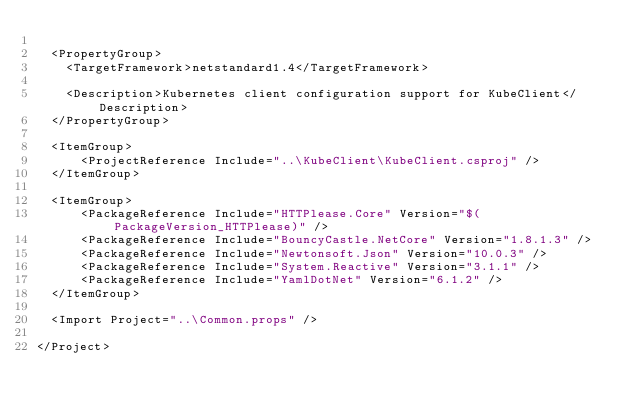<code> <loc_0><loc_0><loc_500><loc_500><_XML_>
  <PropertyGroup>
    <TargetFramework>netstandard1.4</TargetFramework>

    <Description>Kubernetes client configuration support for KubeClient</Description>
  </PropertyGroup>

  <ItemGroup>
      <ProjectReference Include="..\KubeClient\KubeClient.csproj" />
  </ItemGroup>

  <ItemGroup>
      <PackageReference Include="HTTPlease.Core" Version="$(PackageVersion_HTTPlease)" />
      <PackageReference Include="BouncyCastle.NetCore" Version="1.8.1.3" />
      <PackageReference Include="Newtonsoft.Json" Version="10.0.3" />
      <PackageReference Include="System.Reactive" Version="3.1.1" />
      <PackageReference Include="YamlDotNet" Version="6.1.2" />
  </ItemGroup>

  <Import Project="..\Common.props" />

</Project>
</code> 